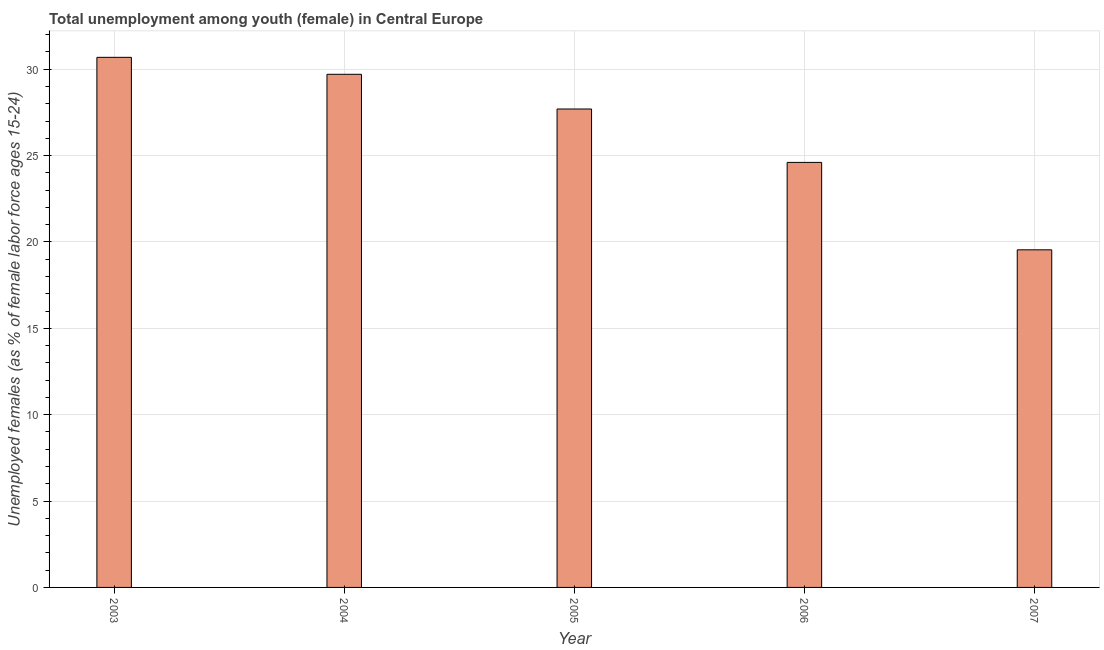What is the title of the graph?
Make the answer very short. Total unemployment among youth (female) in Central Europe. What is the label or title of the Y-axis?
Ensure brevity in your answer.  Unemployed females (as % of female labor force ages 15-24). What is the unemployed female youth population in 2005?
Provide a succinct answer. 27.7. Across all years, what is the maximum unemployed female youth population?
Your answer should be compact. 30.69. Across all years, what is the minimum unemployed female youth population?
Your answer should be very brief. 19.55. In which year was the unemployed female youth population maximum?
Keep it short and to the point. 2003. What is the sum of the unemployed female youth population?
Offer a terse response. 132.25. What is the difference between the unemployed female youth population in 2003 and 2006?
Provide a succinct answer. 6.08. What is the average unemployed female youth population per year?
Keep it short and to the point. 26.45. What is the median unemployed female youth population?
Make the answer very short. 27.7. Do a majority of the years between 2004 and 2005 (inclusive) have unemployed female youth population greater than 21 %?
Your answer should be compact. Yes. What is the ratio of the unemployed female youth population in 2003 to that in 2006?
Your response must be concise. 1.25. Is the difference between the unemployed female youth population in 2004 and 2006 greater than the difference between any two years?
Provide a short and direct response. No. Is the sum of the unemployed female youth population in 2003 and 2006 greater than the maximum unemployed female youth population across all years?
Your answer should be very brief. Yes. What is the difference between the highest and the lowest unemployed female youth population?
Offer a very short reply. 11.14. In how many years, is the unemployed female youth population greater than the average unemployed female youth population taken over all years?
Your response must be concise. 3. How many bars are there?
Offer a terse response. 5. How many years are there in the graph?
Offer a terse response. 5. What is the difference between two consecutive major ticks on the Y-axis?
Provide a short and direct response. 5. Are the values on the major ticks of Y-axis written in scientific E-notation?
Give a very brief answer. No. What is the Unemployed females (as % of female labor force ages 15-24) of 2003?
Offer a terse response. 30.69. What is the Unemployed females (as % of female labor force ages 15-24) of 2004?
Your response must be concise. 29.71. What is the Unemployed females (as % of female labor force ages 15-24) of 2005?
Offer a very short reply. 27.7. What is the Unemployed females (as % of female labor force ages 15-24) in 2006?
Provide a succinct answer. 24.61. What is the Unemployed females (as % of female labor force ages 15-24) in 2007?
Provide a succinct answer. 19.55. What is the difference between the Unemployed females (as % of female labor force ages 15-24) in 2003 and 2004?
Offer a very short reply. 0.98. What is the difference between the Unemployed females (as % of female labor force ages 15-24) in 2003 and 2005?
Make the answer very short. 2.99. What is the difference between the Unemployed females (as % of female labor force ages 15-24) in 2003 and 2006?
Your answer should be very brief. 6.08. What is the difference between the Unemployed females (as % of female labor force ages 15-24) in 2003 and 2007?
Offer a very short reply. 11.14. What is the difference between the Unemployed females (as % of female labor force ages 15-24) in 2004 and 2005?
Make the answer very short. 2.01. What is the difference between the Unemployed females (as % of female labor force ages 15-24) in 2004 and 2006?
Keep it short and to the point. 5.1. What is the difference between the Unemployed females (as % of female labor force ages 15-24) in 2004 and 2007?
Offer a very short reply. 10.16. What is the difference between the Unemployed females (as % of female labor force ages 15-24) in 2005 and 2006?
Provide a short and direct response. 3.09. What is the difference between the Unemployed females (as % of female labor force ages 15-24) in 2005 and 2007?
Make the answer very short. 8.15. What is the difference between the Unemployed females (as % of female labor force ages 15-24) in 2006 and 2007?
Make the answer very short. 5.06. What is the ratio of the Unemployed females (as % of female labor force ages 15-24) in 2003 to that in 2004?
Offer a terse response. 1.03. What is the ratio of the Unemployed females (as % of female labor force ages 15-24) in 2003 to that in 2005?
Your response must be concise. 1.11. What is the ratio of the Unemployed females (as % of female labor force ages 15-24) in 2003 to that in 2006?
Offer a terse response. 1.25. What is the ratio of the Unemployed females (as % of female labor force ages 15-24) in 2003 to that in 2007?
Your answer should be compact. 1.57. What is the ratio of the Unemployed females (as % of female labor force ages 15-24) in 2004 to that in 2005?
Your response must be concise. 1.07. What is the ratio of the Unemployed females (as % of female labor force ages 15-24) in 2004 to that in 2006?
Make the answer very short. 1.21. What is the ratio of the Unemployed females (as % of female labor force ages 15-24) in 2004 to that in 2007?
Make the answer very short. 1.52. What is the ratio of the Unemployed females (as % of female labor force ages 15-24) in 2005 to that in 2006?
Ensure brevity in your answer.  1.13. What is the ratio of the Unemployed females (as % of female labor force ages 15-24) in 2005 to that in 2007?
Provide a succinct answer. 1.42. What is the ratio of the Unemployed females (as % of female labor force ages 15-24) in 2006 to that in 2007?
Offer a very short reply. 1.26. 